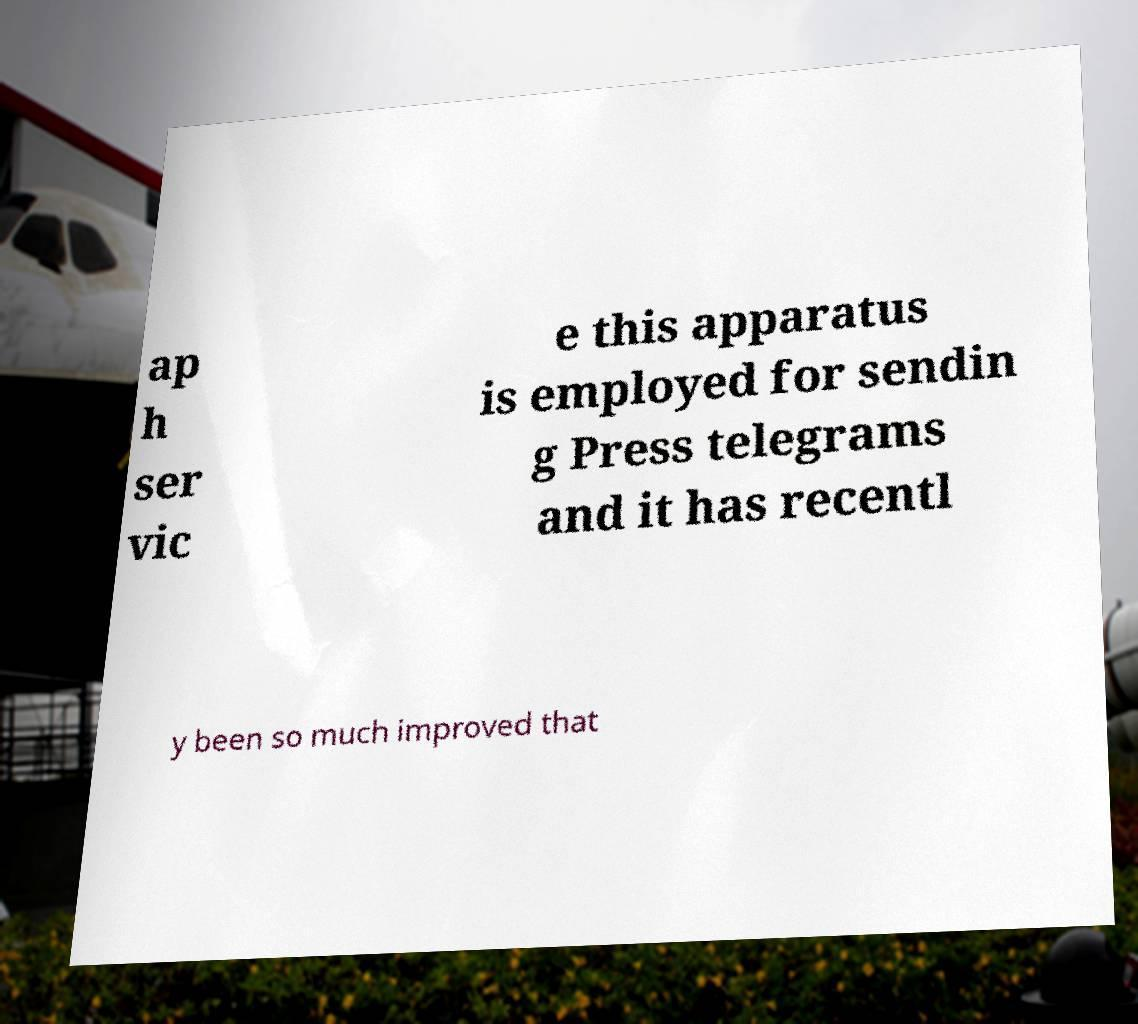For documentation purposes, I need the text within this image transcribed. Could you provide that? ap h ser vic e this apparatus is employed for sendin g Press telegrams and it has recentl y been so much improved that 